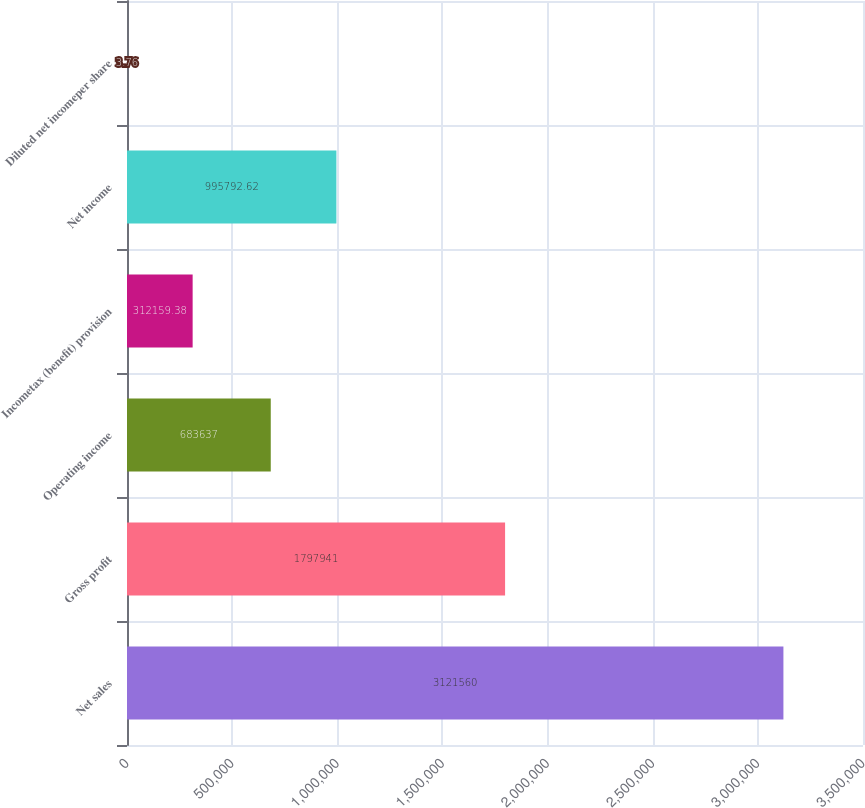Convert chart to OTSL. <chart><loc_0><loc_0><loc_500><loc_500><bar_chart><fcel>Net sales<fcel>Gross profit<fcel>Operating income<fcel>Incometax (benefit) provision<fcel>Net income<fcel>Diluted net incomeper share<nl><fcel>3.12156e+06<fcel>1.79794e+06<fcel>683637<fcel>312159<fcel>995793<fcel>3.76<nl></chart> 